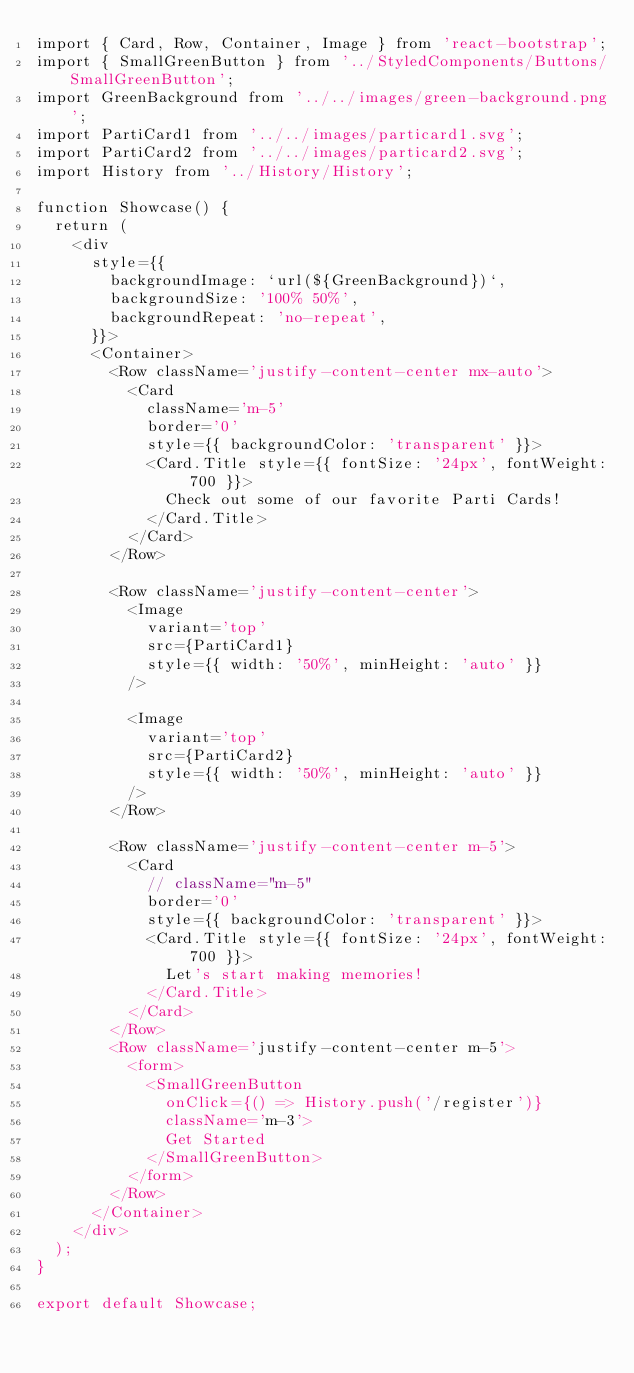Convert code to text. <code><loc_0><loc_0><loc_500><loc_500><_JavaScript_>import { Card, Row, Container, Image } from 'react-bootstrap';
import { SmallGreenButton } from '../StyledComponents/Buttons/SmallGreenButton';
import GreenBackground from '../../images/green-background.png';
import PartiCard1 from '../../images/particard1.svg';
import PartiCard2 from '../../images/particard2.svg';
import History from '../History/History';

function Showcase() {
	return (
		<div
			style={{
				backgroundImage: `url(${GreenBackground})`,
				backgroundSize: '100% 50%',
				backgroundRepeat: 'no-repeat',
			}}>
			<Container>
				<Row className='justify-content-center mx-auto'>
					<Card
						className='m-5'
						border='0'
						style={{ backgroundColor: 'transparent' }}>
						<Card.Title style={{ fontSize: '24px', fontWeight: 700 }}>
							Check out some of our favorite Parti Cards!
						</Card.Title>
					</Card>
				</Row>

				<Row className='justify-content-center'>
					<Image
						variant='top'
						src={PartiCard1}
						style={{ width: '50%', minHeight: 'auto' }}
					/>

					<Image
						variant='top'
						src={PartiCard2}
						style={{ width: '50%', minHeight: 'auto' }}
					/>
				</Row>

				<Row className='justify-content-center m-5'>
					<Card
						// className="m-5"
						border='0'
						style={{ backgroundColor: 'transparent' }}>
						<Card.Title style={{ fontSize: '24px', fontWeight: 700 }}>
							Let's start making memories!
						</Card.Title>
					</Card>
				</Row>
				<Row className='justify-content-center m-5'>
					<form>
						<SmallGreenButton
							onClick={() => History.push('/register')}
							className='m-3'>
							Get Started
						</SmallGreenButton>
					</form>
				</Row>
			</Container>
		</div>
	);
}

export default Showcase;
</code> 